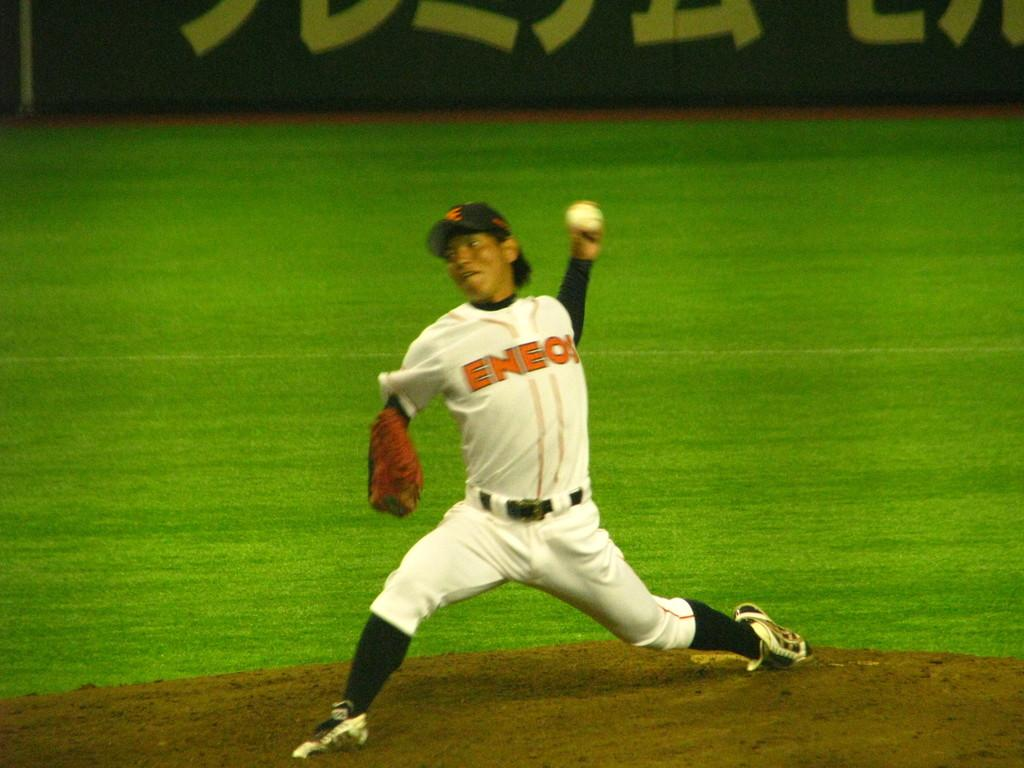<image>
Present a compact description of the photo's key features. a person with the letters ENE on his jersey 